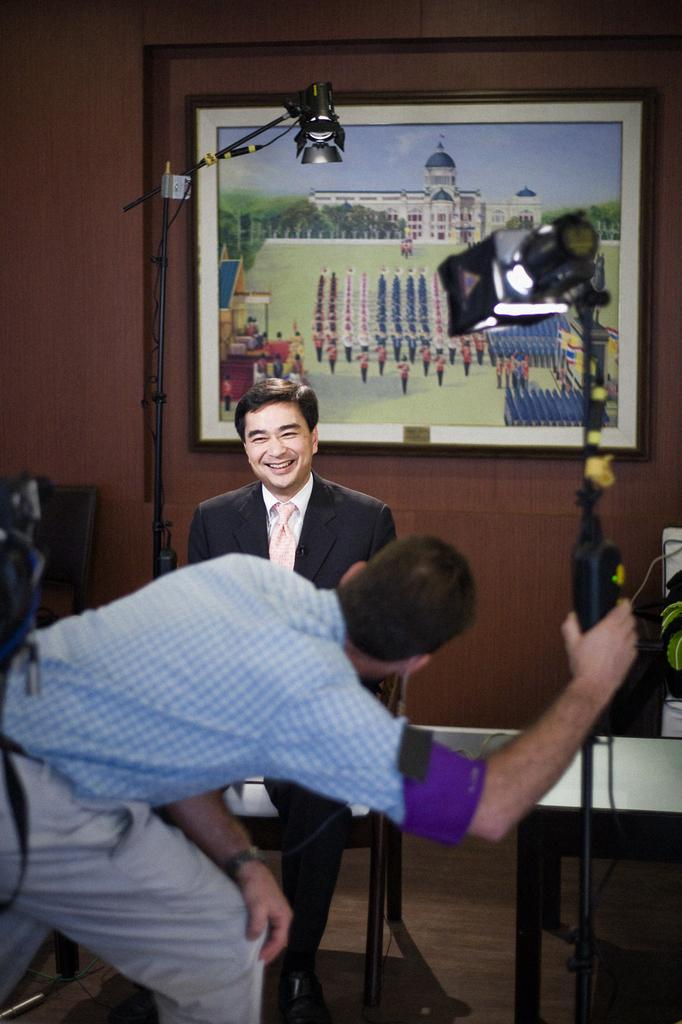Who is the main subject in the image? There is a man in the image. What is the man doing in the image? The man is smiling. What is the man wearing in the image? The man is wearing a black suit. Who else is present in the image? There is another person in the image. What is the second person doing in the image? The second person is taking a photo of the man. What can be seen on the wall in the image? There is a frame on the wall. What type of polish is the man applying to his brain in the image? There is no mention of polish or the man applying anything to his brain in the image. 